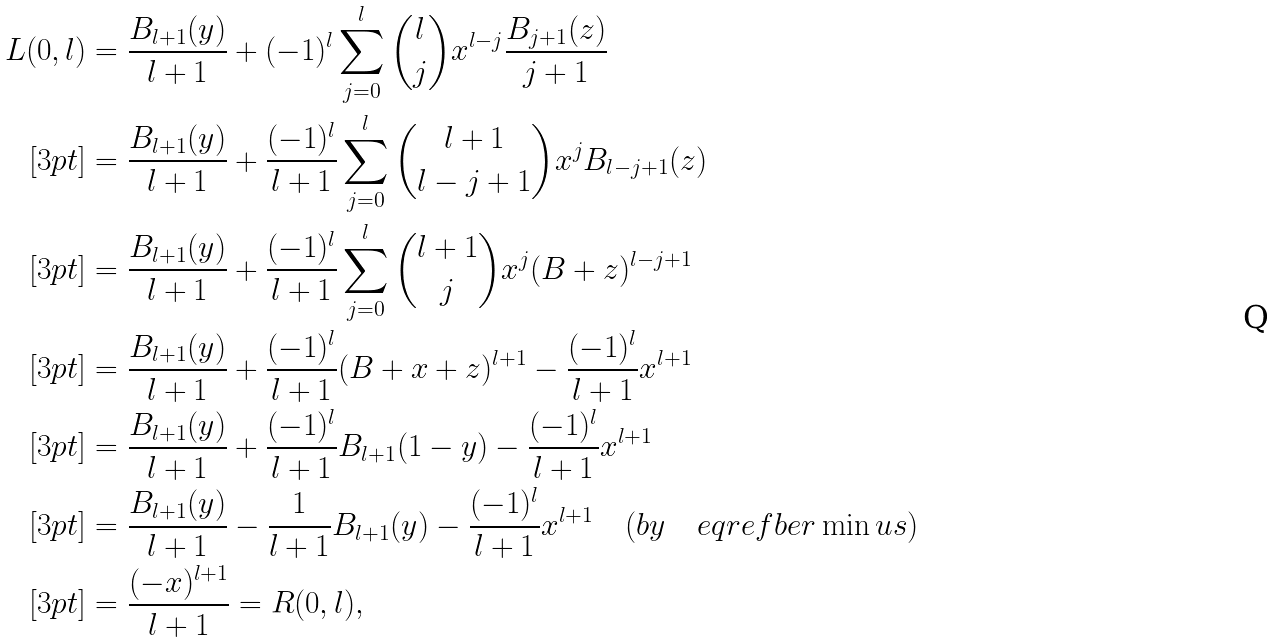<formula> <loc_0><loc_0><loc_500><loc_500>L ( 0 , l ) & = \frac { B _ { l + 1 } ( y ) } { l + 1 } + ( - 1 ) ^ { l } \sum _ { j = 0 } ^ { l } { l \choose j } x ^ { l - j } \frac { B _ { j + 1 } ( z ) } { j + 1 } \\ [ 3 p t ] & = \frac { B _ { l + 1 } ( y ) } { l + 1 } + \frac { ( - 1 ) ^ { l } } { l + 1 } \sum _ { j = 0 } ^ { l } { l + 1 \choose l - j + 1 } x ^ { j } B _ { l - j + 1 } ( z ) \\ [ 3 p t ] & = \frac { B _ { l + 1 } ( y ) } { l + 1 } + \frac { ( - 1 ) ^ { l } } { l + 1 } \sum _ { j = 0 } ^ { l } { l + 1 \choose j } x ^ { j } ( B + z ) ^ { l - j + 1 } \\ [ 3 p t ] & = \frac { B _ { l + 1 } ( y ) } { l + 1 } + \frac { ( - 1 ) ^ { l } } { l + 1 } ( B + x + z ) ^ { l + 1 } - \frac { ( - 1 ) ^ { l } } { l + 1 } x ^ { l + 1 } \\ [ 3 p t ] & = \frac { B _ { l + 1 } ( y ) } { l + 1 } + \frac { ( - 1 ) ^ { l } } { l + 1 } B _ { l + 1 } ( 1 - y ) - \frac { ( - 1 ) ^ { l } } { l + 1 } x ^ { l + 1 } \\ [ 3 p t ] & = \frac { B _ { l + 1 } ( y ) } { l + 1 } - \frac { 1 } { l + 1 } B _ { l + 1 } ( y ) - \frac { ( - 1 ) ^ { l } } { l + 1 } x ^ { l + 1 } \quad ( b y \quad e q r e f { b e r \min u s } ) \\ [ 3 p t ] & = \frac { ( - x ) ^ { l + 1 } } { l + 1 } = R ( 0 , l ) ,</formula> 